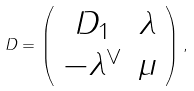Convert formula to latex. <formula><loc_0><loc_0><loc_500><loc_500>D = \left ( \begin{array} { c c } D _ { 1 } & \lambda \\ - \lambda ^ { \vee } & \mu \end{array} \right ) ,</formula> 